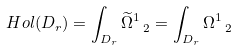<formula> <loc_0><loc_0><loc_500><loc_500>H o l ( D _ { r } ) = \int _ { D _ { r } } \widetilde { \Omega } ^ { 1 } _ { \ 2 } = \int _ { D _ { r } } \Omega ^ { 1 } _ { \ 2 }</formula> 